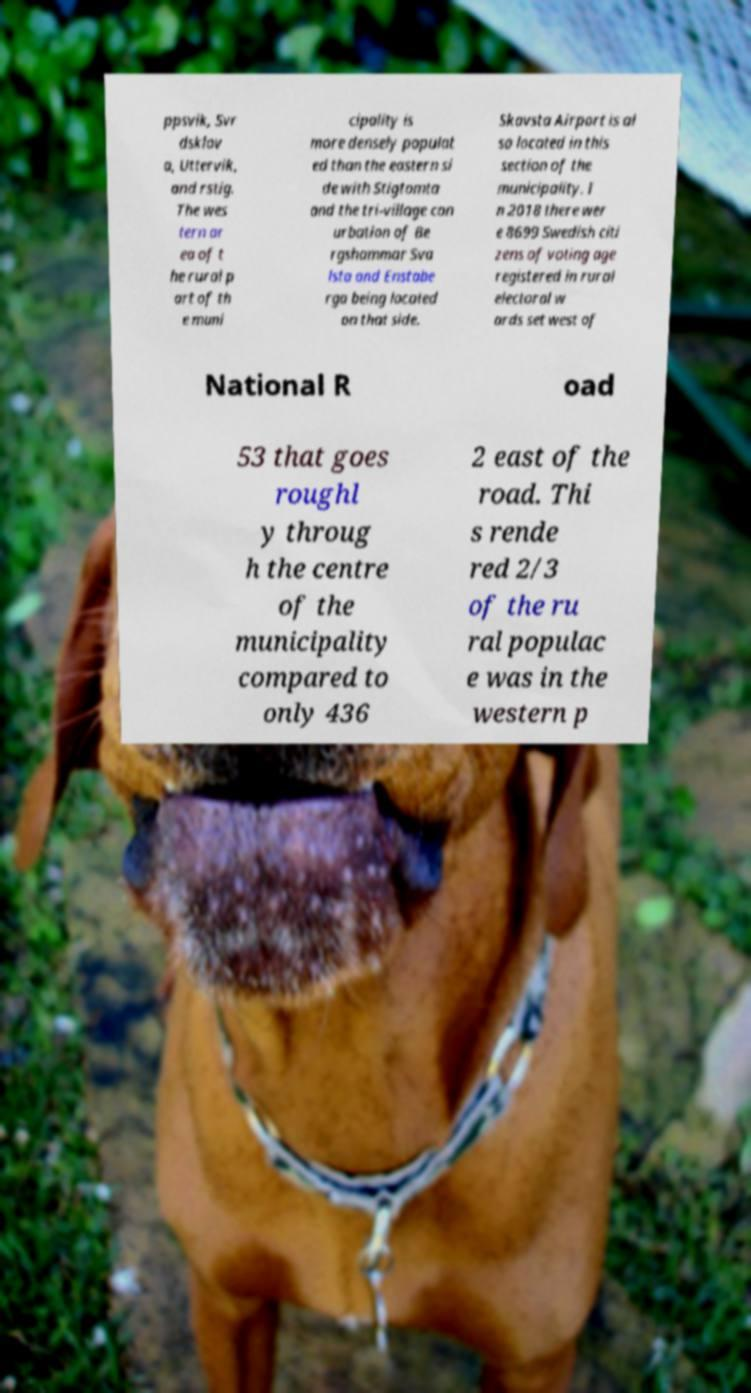Can you read and provide the text displayed in the image?This photo seems to have some interesting text. Can you extract and type it out for me? ppsvik, Svr dsklov a, Uttervik, and rstig. The wes tern ar ea of t he rural p art of th e muni cipality is more densely populat ed than the eastern si de with Stigtomta and the tri-village con urbation of Be rgshammar Sva lsta and Enstabe rga being located on that side. Skavsta Airport is al so located in this section of the municipality. I n 2018 there wer e 8699 Swedish citi zens of voting age registered in rural electoral w ards set west of National R oad 53 that goes roughl y throug h the centre of the municipality compared to only 436 2 east of the road. Thi s rende red 2/3 of the ru ral populac e was in the western p 